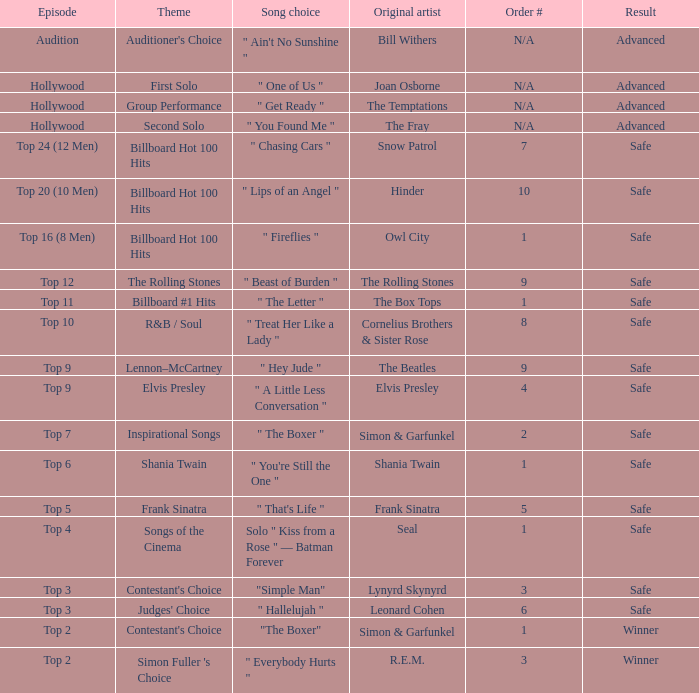In which episode is the order number 10? Top 20 (10 Men). Give me the full table as a dictionary. {'header': ['Episode', 'Theme', 'Song choice', 'Original artist', 'Order #', 'Result'], 'rows': [['Audition', "Auditioner's Choice", '" Ain\'t No Sunshine "', 'Bill Withers', 'N/A', 'Advanced'], ['Hollywood', 'First Solo', '" One of Us "', 'Joan Osborne', 'N/A', 'Advanced'], ['Hollywood', 'Group Performance', '" Get Ready "', 'The Temptations', 'N/A', 'Advanced'], ['Hollywood', 'Second Solo', '" You Found Me "', 'The Fray', 'N/A', 'Advanced'], ['Top 24 (12 Men)', 'Billboard Hot 100 Hits', '" Chasing Cars "', 'Snow Patrol', '7', 'Safe'], ['Top 20 (10 Men)', 'Billboard Hot 100 Hits', '" Lips of an Angel "', 'Hinder', '10', 'Safe'], ['Top 16 (8 Men)', 'Billboard Hot 100 Hits', '" Fireflies "', 'Owl City', '1', 'Safe'], ['Top 12', 'The Rolling Stones', '" Beast of Burden "', 'The Rolling Stones', '9', 'Safe'], ['Top 11', 'Billboard #1 Hits', '" The Letter "', 'The Box Tops', '1', 'Safe'], ['Top 10', 'R&B / Soul', '" Treat Her Like a Lady "', 'Cornelius Brothers & Sister Rose', '8', 'Safe'], ['Top 9', 'Lennon–McCartney', '" Hey Jude "', 'The Beatles', '9', 'Safe'], ['Top 9', 'Elvis Presley', '" A Little Less Conversation "', 'Elvis Presley', '4', 'Safe'], ['Top 7', 'Inspirational Songs', '" The Boxer "', 'Simon & Garfunkel', '2', 'Safe'], ['Top 6', 'Shania Twain', '" You\'re Still the One "', 'Shania Twain', '1', 'Safe'], ['Top 5', 'Frank Sinatra', '" That\'s Life "', 'Frank Sinatra', '5', 'Safe'], ['Top 4', 'Songs of the Cinema', 'Solo " Kiss from a Rose " — Batman Forever', 'Seal', '1', 'Safe'], ['Top 3', "Contestant's Choice", '"Simple Man"', 'Lynyrd Skynyrd', '3', 'Safe'], ['Top 3', "Judges' Choice", '" Hallelujah "', 'Leonard Cohen', '6', 'Safe'], ['Top 2', "Contestant's Choice", '"The Boxer"', 'Simon & Garfunkel', '1', 'Winner'], ['Top 2', "Simon Fuller 's Choice", '" Everybody Hurts "', 'R.E.M.', '3', 'Winner']]} 